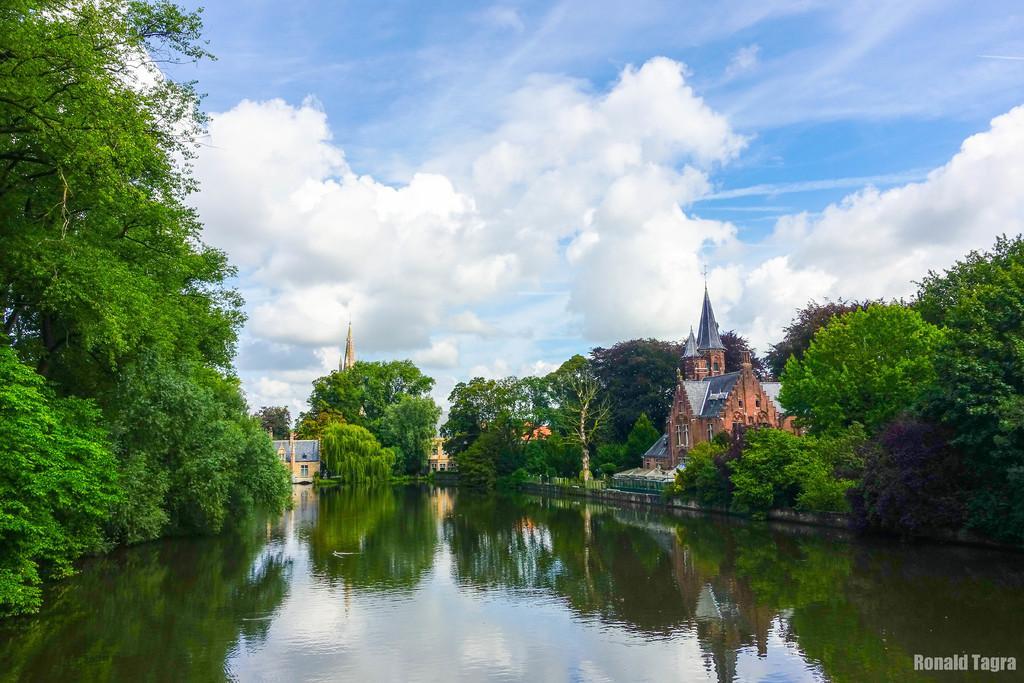Please provide a concise description of this image. In this picture we can see water, few trees, houses and clouds. 